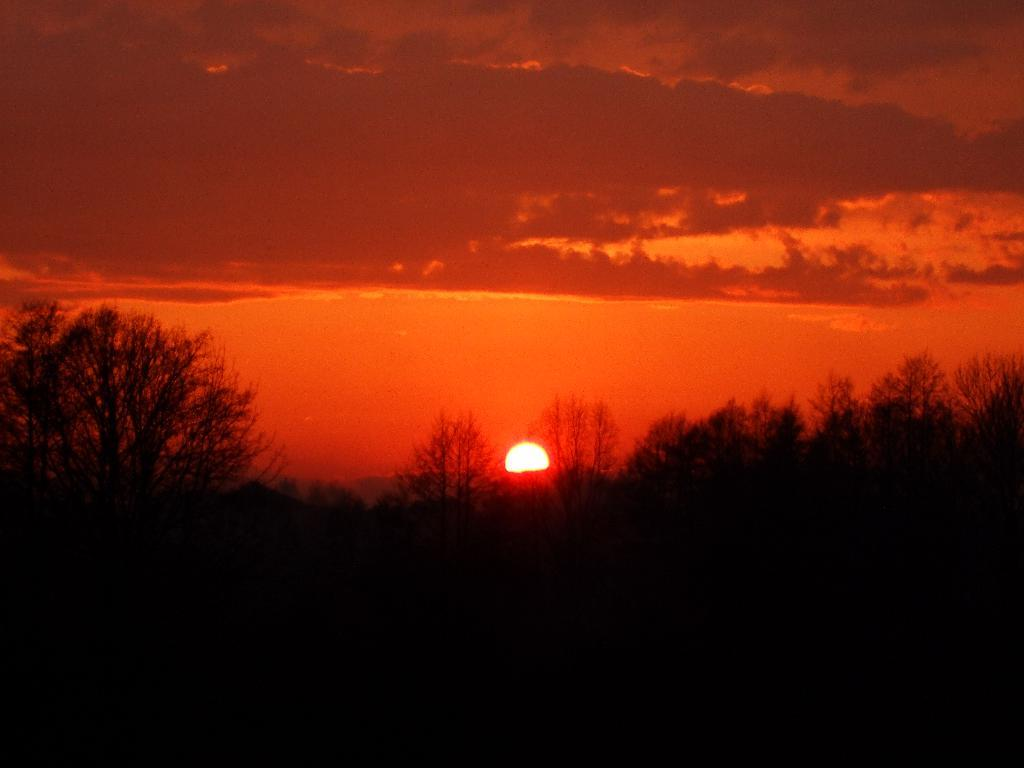What type of vegetation is at the bottom of the image? There are trees at the bottom of the image. What celestial body is in the middle of the image? There is a sun in the middle of the image. What is the condition of the sky at the top of the image? The sky is cloudy at the top of the image. What substance is being moved by the trees in the image? There is no substance being moved by the trees in the image; the trees are stationary. What is located at the back of the image? The provided facts do not mention anything being present at the back of the image. 